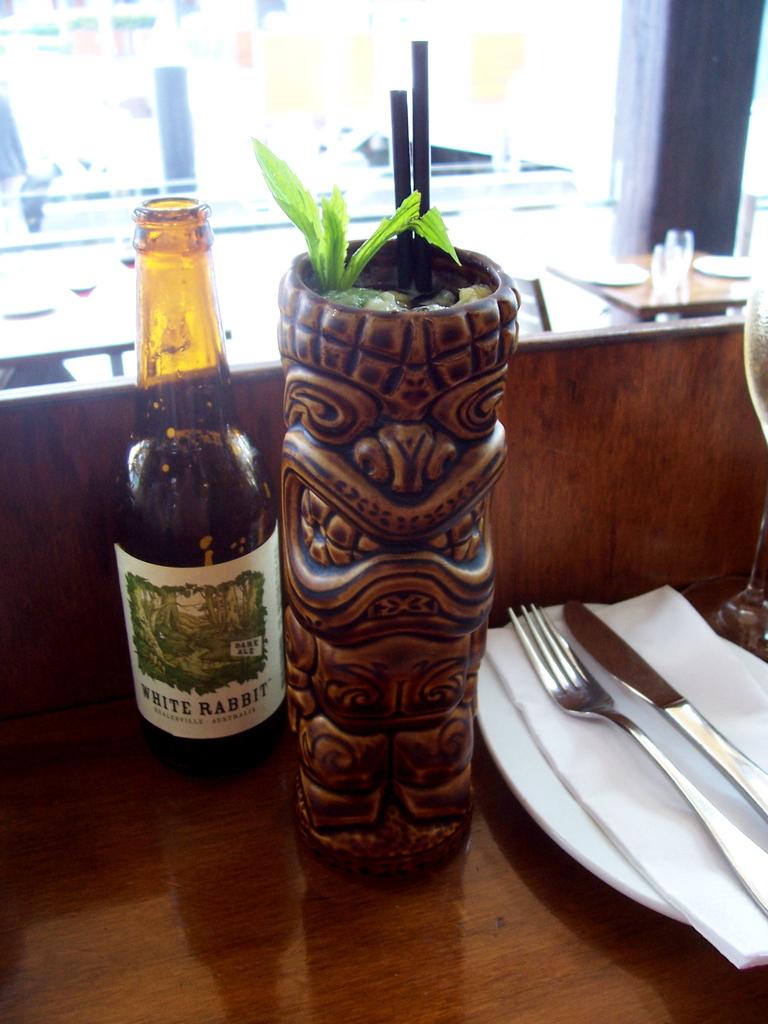What is the brand of beverage?
Offer a very short reply. White rabbit. 